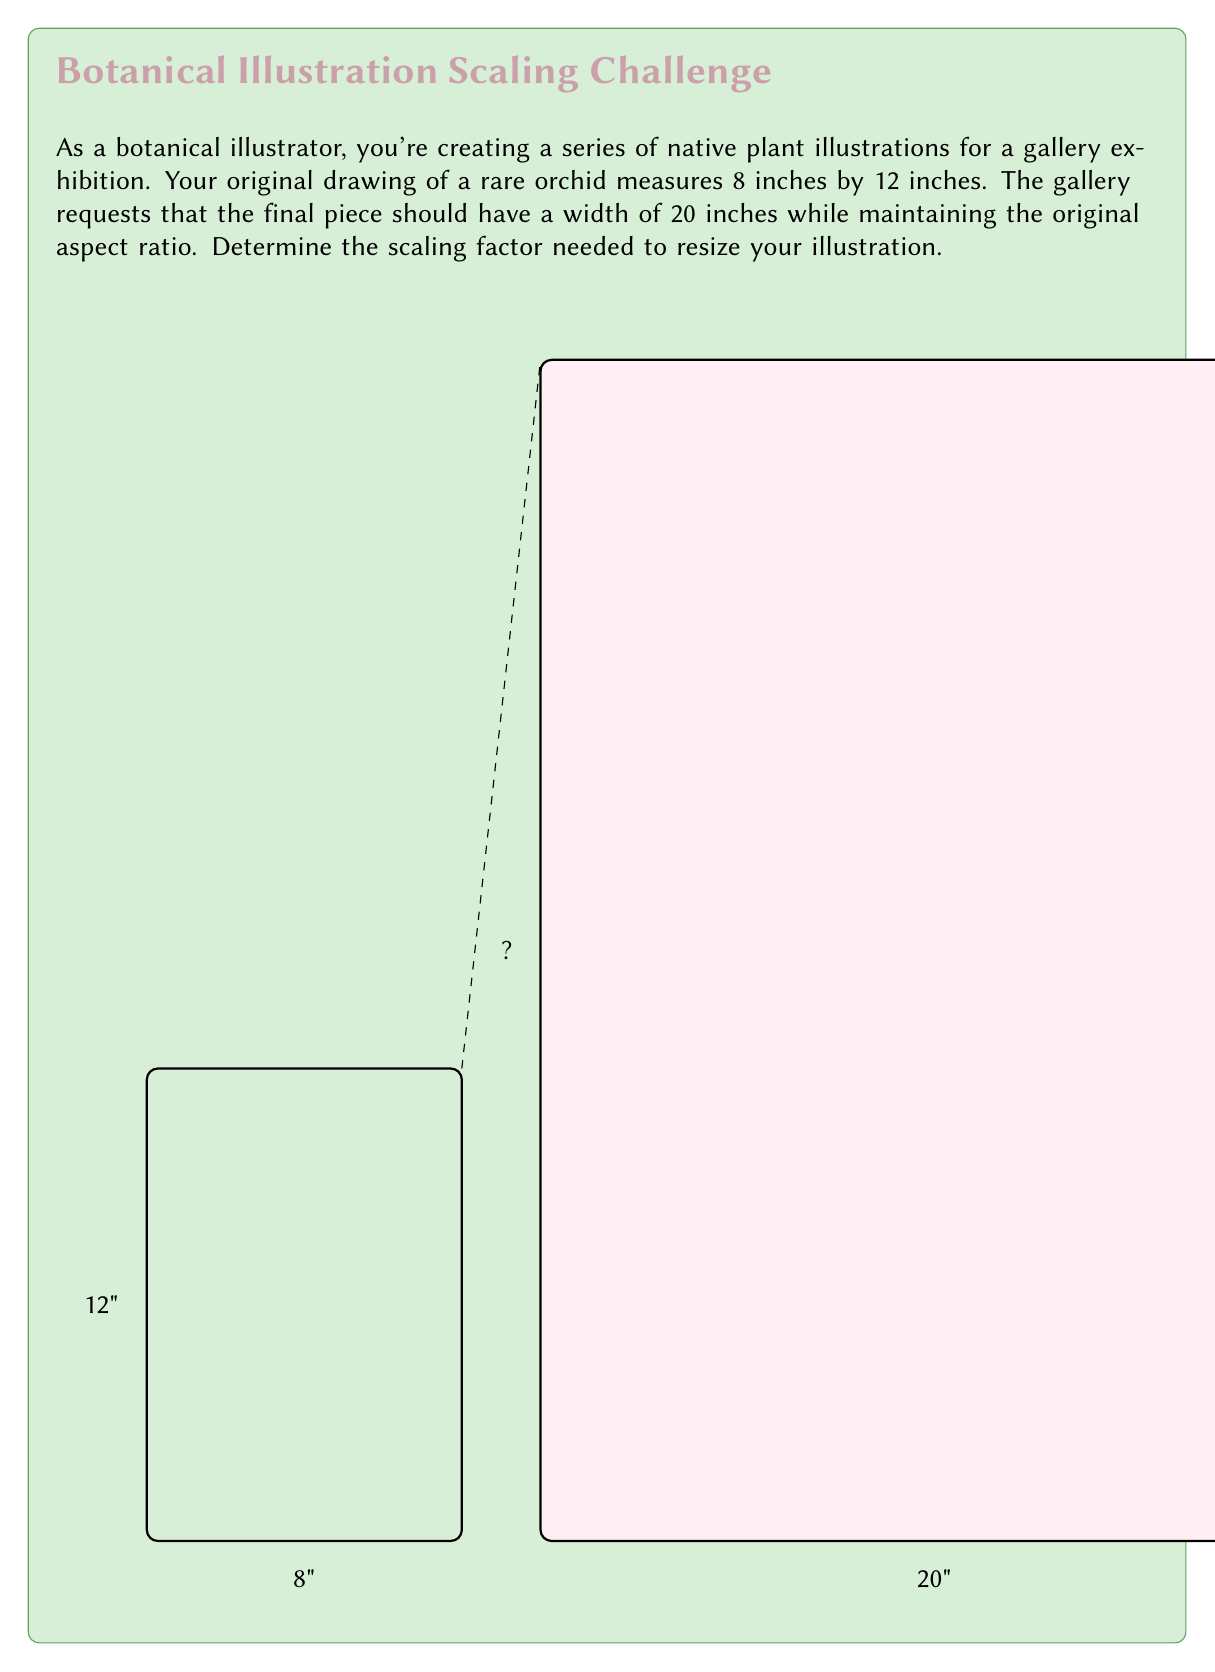What is the answer to this math problem? To determine the scaling factor, we need to compare the new width to the original width. Let's approach this step-by-step:

1) Original dimensions: 8 inches × 12 inches
2) New width: 20 inches

The scaling factor is the ratio of the new dimension to the original dimension. We can calculate this using the width:

$$ \text{Scaling factor} = \frac{\text{New width}}{\text{Original width}} $$

$$ \text{Scaling factor} = \frac{20 \text{ inches}}{8 \text{ inches}} $$

$$ \text{Scaling factor} = \frac{20}{8} = \frac{5}{2} = 2.5 $$

To verify, let's check if this scaling factor maintains the aspect ratio:

- New width: $8 \times 2.5 = 20$ inches (matches the required width)
- New height: $12 \times 2.5 = 30$ inches

The new dimensions (20" × 30") maintain the original 2:3 aspect ratio.

Therefore, you need to scale your original illustration by a factor of 2.5 to achieve the desired size while maintaining the aspect ratio.
Answer: $2.5$ 